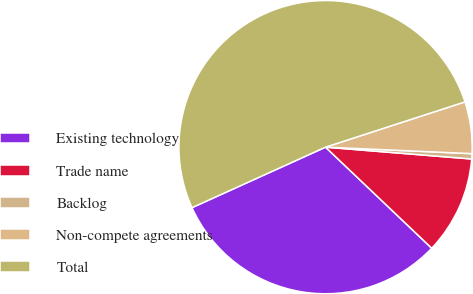<chart> <loc_0><loc_0><loc_500><loc_500><pie_chart><fcel>Existing technology<fcel>Trade name<fcel>Backlog<fcel>Non-compete agreements<fcel>Total<nl><fcel>31.12%<fcel>10.82%<fcel>0.58%<fcel>5.7%<fcel>51.77%<nl></chart> 